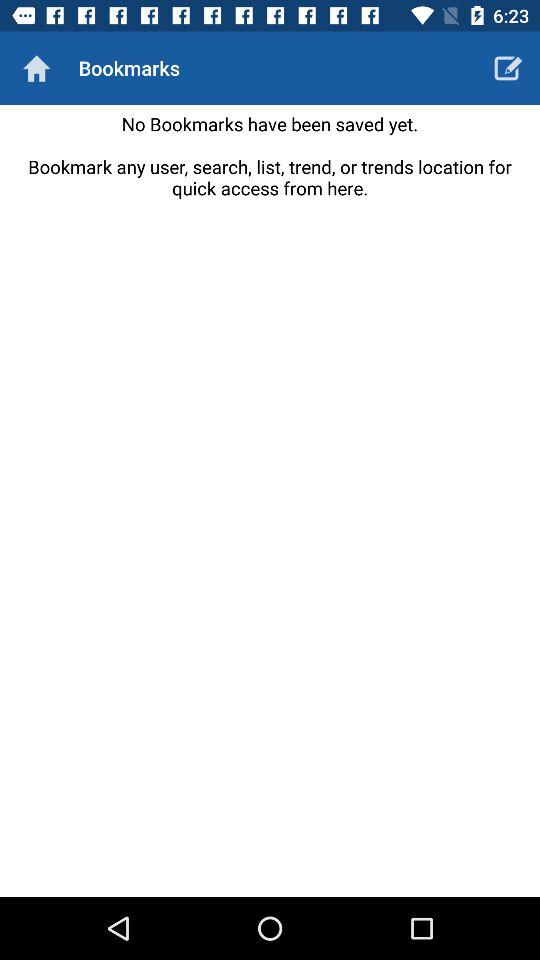How many bookmarks have been saved?
Answer the question using a single word or phrase. 0 